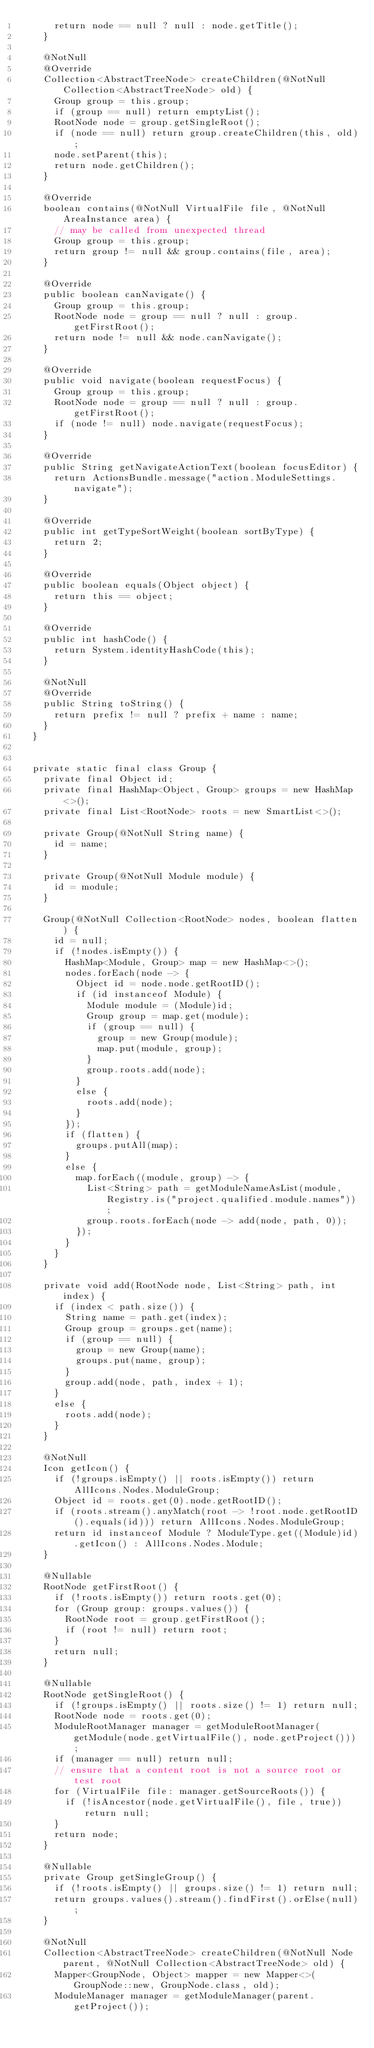<code> <loc_0><loc_0><loc_500><loc_500><_Java_>      return node == null ? null : node.getTitle();
    }

    @NotNull
    @Override
    Collection<AbstractTreeNode> createChildren(@NotNull Collection<AbstractTreeNode> old) {
      Group group = this.group;
      if (group == null) return emptyList();
      RootNode node = group.getSingleRoot();
      if (node == null) return group.createChildren(this, old);
      node.setParent(this);
      return node.getChildren();
    }

    @Override
    boolean contains(@NotNull VirtualFile file, @NotNull AreaInstance area) {
      // may be called from unexpected thread
      Group group = this.group;
      return group != null && group.contains(file, area);
    }

    @Override
    public boolean canNavigate() {
      Group group = this.group;
      RootNode node = group == null ? null : group.getFirstRoot();
      return node != null && node.canNavigate();
    }

    @Override
    public void navigate(boolean requestFocus) {
      Group group = this.group;
      RootNode node = group == null ? null : group.getFirstRoot();
      if (node != null) node.navigate(requestFocus);
    }

    @Override
    public String getNavigateActionText(boolean focusEditor) {
      return ActionsBundle.message("action.ModuleSettings.navigate");
    }

    @Override
    public int getTypeSortWeight(boolean sortByType) {
      return 2;
    }

    @Override
    public boolean equals(Object object) {
      return this == object;
    }

    @Override
    public int hashCode() {
      return System.identityHashCode(this);
    }

    @NotNull
    @Override
    public String toString() {
      return prefix != null ? prefix + name : name;
    }
  }


  private static final class Group {
    private final Object id;
    private final HashMap<Object, Group> groups = new HashMap<>();
    private final List<RootNode> roots = new SmartList<>();

    private Group(@NotNull String name) {
      id = name;
    }

    private Group(@NotNull Module module) {
      id = module;
    }

    Group(@NotNull Collection<RootNode> nodes, boolean flatten) {
      id = null;
      if (!nodes.isEmpty()) {
        HashMap<Module, Group> map = new HashMap<>();
        nodes.forEach(node -> {
          Object id = node.node.getRootID();
          if (id instanceof Module) {
            Module module = (Module)id;
            Group group = map.get(module);
            if (group == null) {
              group = new Group(module);
              map.put(module, group);
            }
            group.roots.add(node);
          }
          else {
            roots.add(node);
          }
        });
        if (flatten) {
          groups.putAll(map);
        }
        else {
          map.forEach((module, group) -> {
            List<String> path = getModuleNameAsList(module, Registry.is("project.qualified.module.names"));
            group.roots.forEach(node -> add(node, path, 0));
          });
        }
      }
    }

    private void add(RootNode node, List<String> path, int index) {
      if (index < path.size()) {
        String name = path.get(index);
        Group group = groups.get(name);
        if (group == null) {
          group = new Group(name);
          groups.put(name, group);
        }
        group.add(node, path, index + 1);
      }
      else {
        roots.add(node);
      }
    }

    @NotNull
    Icon getIcon() {
      if (!groups.isEmpty() || roots.isEmpty()) return AllIcons.Nodes.ModuleGroup;
      Object id = roots.get(0).node.getRootID();
      if (roots.stream().anyMatch(root -> !root.node.getRootID().equals(id))) return AllIcons.Nodes.ModuleGroup;
      return id instanceof Module ? ModuleType.get((Module)id).getIcon() : AllIcons.Nodes.Module;
    }

    @Nullable
    RootNode getFirstRoot() {
      if (!roots.isEmpty()) return roots.get(0);
      for (Group group: groups.values()) {
        RootNode root = group.getFirstRoot();
        if (root != null) return root;
      }
      return null;
    }

    @Nullable
    RootNode getSingleRoot() {
      if (!groups.isEmpty() || roots.size() != 1) return null;
      RootNode node = roots.get(0);
      ModuleRootManager manager = getModuleRootManager(getModule(node.getVirtualFile(), node.getProject()));
      if (manager == null) return null;
      // ensure that a content root is not a source root or test root
      for (VirtualFile file: manager.getSourceRoots()) {
        if (!isAncestor(node.getVirtualFile(), file, true)) return null;
      }
      return node;
    }

    @Nullable
    private Group getSingleGroup() {
      if (!roots.isEmpty() || groups.size() != 1) return null;
      return groups.values().stream().findFirst().orElse(null);
    }

    @NotNull
    Collection<AbstractTreeNode> createChildren(@NotNull Node parent, @NotNull Collection<AbstractTreeNode> old) {
      Mapper<GroupNode, Object> mapper = new Mapper<>(GroupNode::new, GroupNode.class, old);
      ModuleManager manager = getModuleManager(parent.getProject());</code> 